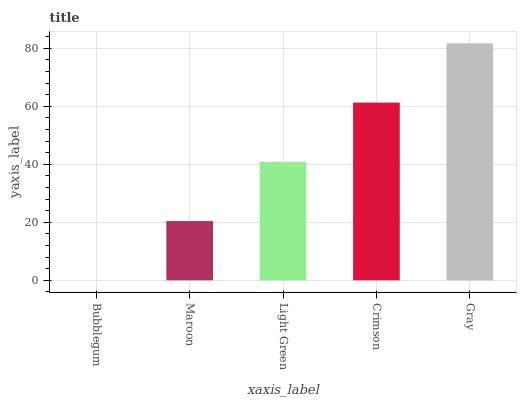Is Maroon the minimum?
Answer yes or no. No. Is Maroon the maximum?
Answer yes or no. No. Is Maroon greater than Bubblegum?
Answer yes or no. Yes. Is Bubblegum less than Maroon?
Answer yes or no. Yes. Is Bubblegum greater than Maroon?
Answer yes or no. No. Is Maroon less than Bubblegum?
Answer yes or no. No. Is Light Green the high median?
Answer yes or no. Yes. Is Light Green the low median?
Answer yes or no. Yes. Is Bubblegum the high median?
Answer yes or no. No. Is Crimson the low median?
Answer yes or no. No. 